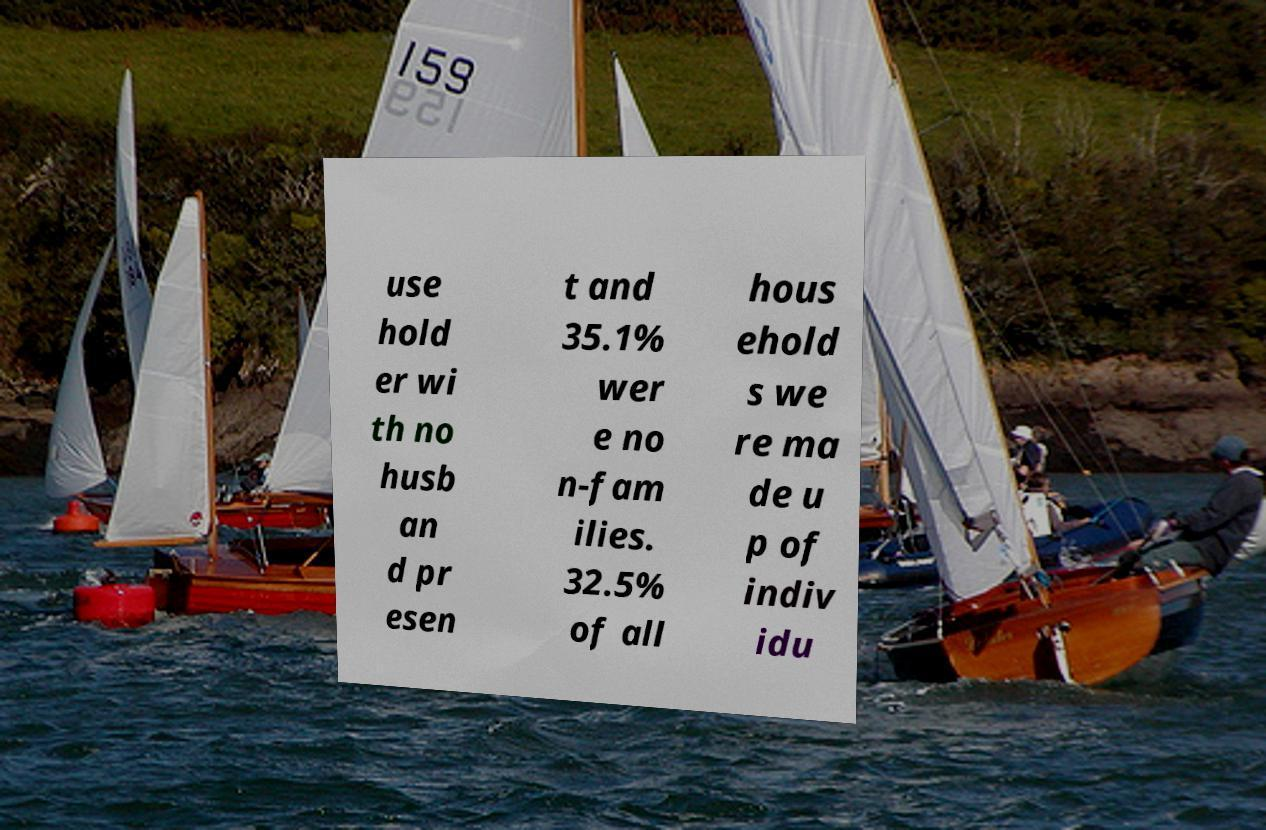For documentation purposes, I need the text within this image transcribed. Could you provide that? use hold er wi th no husb an d pr esen t and 35.1% wer e no n-fam ilies. 32.5% of all hous ehold s we re ma de u p of indiv idu 